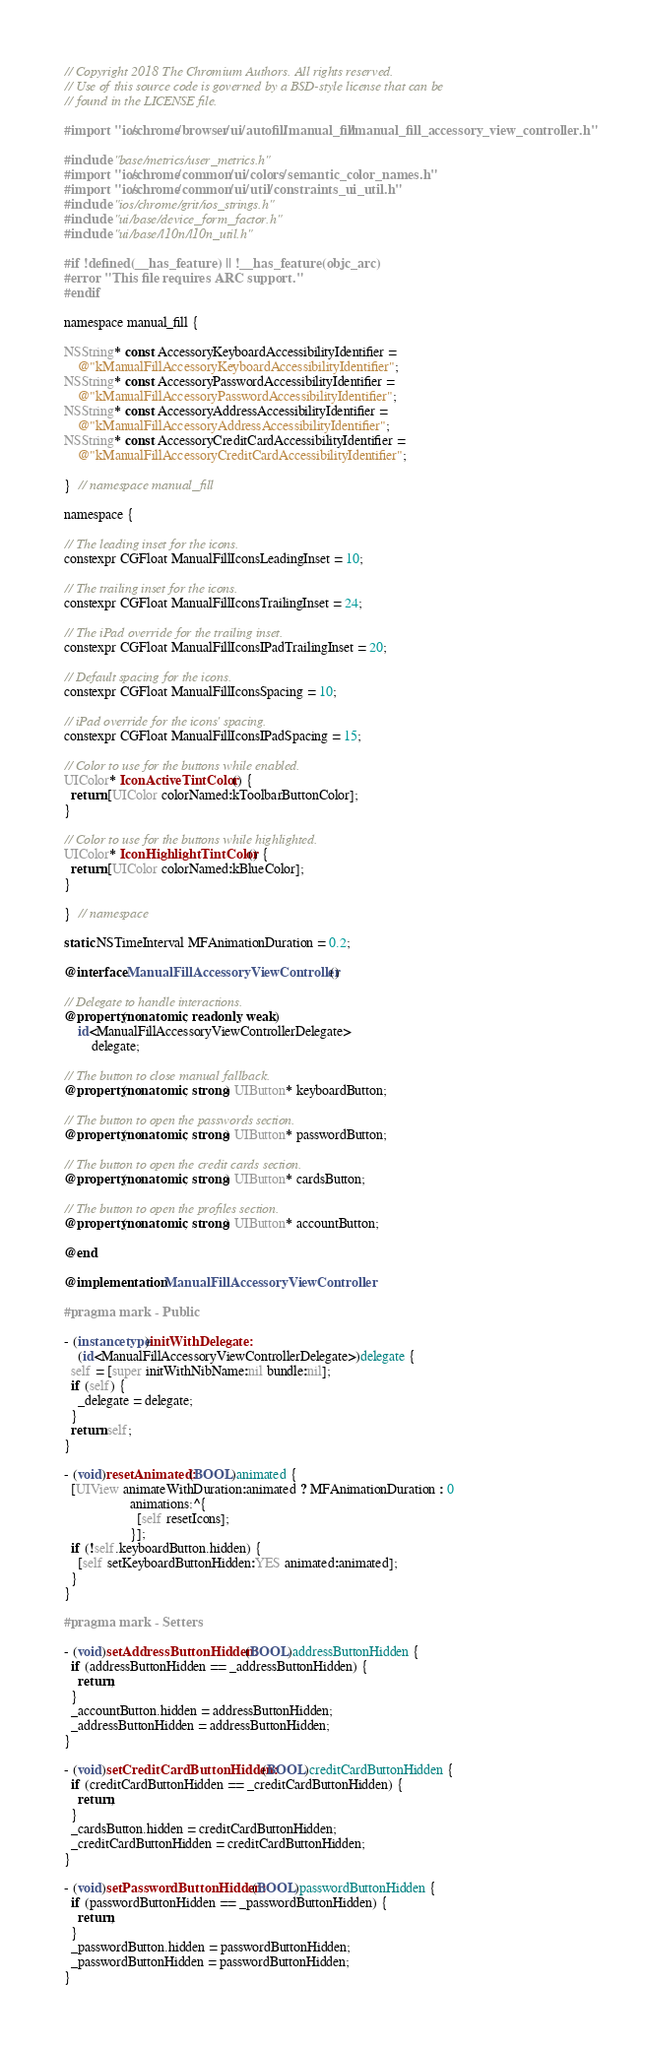<code> <loc_0><loc_0><loc_500><loc_500><_ObjectiveC_>// Copyright 2018 The Chromium Authors. All rights reserved.
// Use of this source code is governed by a BSD-style license that can be
// found in the LICENSE file.

#import "ios/chrome/browser/ui/autofill/manual_fill/manual_fill_accessory_view_controller.h"

#include "base/metrics/user_metrics.h"
#import "ios/chrome/common/ui/colors/semantic_color_names.h"
#import "ios/chrome/common/ui/util/constraints_ui_util.h"
#include "ios/chrome/grit/ios_strings.h"
#include "ui/base/device_form_factor.h"
#include "ui/base/l10n/l10n_util.h"

#if !defined(__has_feature) || !__has_feature(objc_arc)
#error "This file requires ARC support."
#endif

namespace manual_fill {

NSString* const AccessoryKeyboardAccessibilityIdentifier =
    @"kManualFillAccessoryKeyboardAccessibilityIdentifier";
NSString* const AccessoryPasswordAccessibilityIdentifier =
    @"kManualFillAccessoryPasswordAccessibilityIdentifier";
NSString* const AccessoryAddressAccessibilityIdentifier =
    @"kManualFillAccessoryAddressAccessibilityIdentifier";
NSString* const AccessoryCreditCardAccessibilityIdentifier =
    @"kManualFillAccessoryCreditCardAccessibilityIdentifier";

}  // namespace manual_fill

namespace {

// The leading inset for the icons.
constexpr CGFloat ManualFillIconsLeadingInset = 10;

// The trailing inset for the icons.
constexpr CGFloat ManualFillIconsTrailingInset = 24;

// The iPad override for the trailing inset.
constexpr CGFloat ManualFillIconsIPadTrailingInset = 20;

// Default spacing for the icons.
constexpr CGFloat ManualFillIconsSpacing = 10;

// iPad override for the icons' spacing.
constexpr CGFloat ManualFillIconsIPadSpacing = 15;

// Color to use for the buttons while enabled.
UIColor* IconActiveTintColor() {
  return [UIColor colorNamed:kToolbarButtonColor];
}

// Color to use for the buttons while highlighted.
UIColor* IconHighlightTintColor() {
  return [UIColor colorNamed:kBlueColor];
}

}  // namespace

static NSTimeInterval MFAnimationDuration = 0.2;

@interface ManualFillAccessoryViewController ()

// Delegate to handle interactions.
@property(nonatomic, readonly, weak)
    id<ManualFillAccessoryViewControllerDelegate>
        delegate;

// The button to close manual fallback.
@property(nonatomic, strong) UIButton* keyboardButton;

// The button to open the passwords section.
@property(nonatomic, strong) UIButton* passwordButton;

// The button to open the credit cards section.
@property(nonatomic, strong) UIButton* cardsButton;

// The button to open the profiles section.
@property(nonatomic, strong) UIButton* accountButton;

@end

@implementation ManualFillAccessoryViewController

#pragma mark - Public

- (instancetype)initWithDelegate:
    (id<ManualFillAccessoryViewControllerDelegate>)delegate {
  self = [super initWithNibName:nil bundle:nil];
  if (self) {
    _delegate = delegate;
  }
  return self;
}

- (void)resetAnimated:(BOOL)animated {
  [UIView animateWithDuration:animated ? MFAnimationDuration : 0
                   animations:^{
                     [self resetIcons];
                   }];
  if (!self.keyboardButton.hidden) {
    [self setKeyboardButtonHidden:YES animated:animated];
  }
}

#pragma mark - Setters

- (void)setAddressButtonHidden:(BOOL)addressButtonHidden {
  if (addressButtonHidden == _addressButtonHidden) {
    return;
  }
  _accountButton.hidden = addressButtonHidden;
  _addressButtonHidden = addressButtonHidden;
}

- (void)setCreditCardButtonHidden:(BOOL)creditCardButtonHidden {
  if (creditCardButtonHidden == _creditCardButtonHidden) {
    return;
  }
  _cardsButton.hidden = creditCardButtonHidden;
  _creditCardButtonHidden = creditCardButtonHidden;
}

- (void)setPasswordButtonHidden:(BOOL)passwordButtonHidden {
  if (passwordButtonHidden == _passwordButtonHidden) {
    return;
  }
  _passwordButton.hidden = passwordButtonHidden;
  _passwordButtonHidden = passwordButtonHidden;
}
</code> 